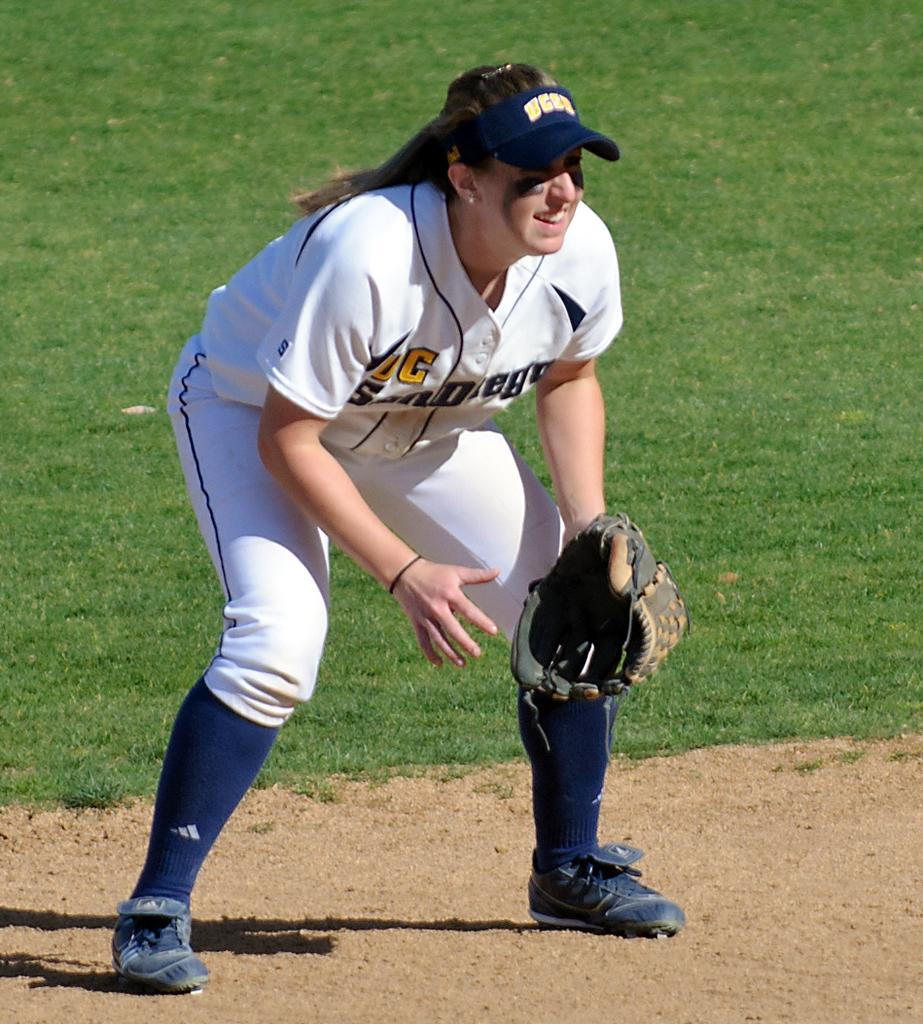<image>
Offer a succinct explanation of the picture presented. A female baseball player with the logo for ucsa on her hat. 